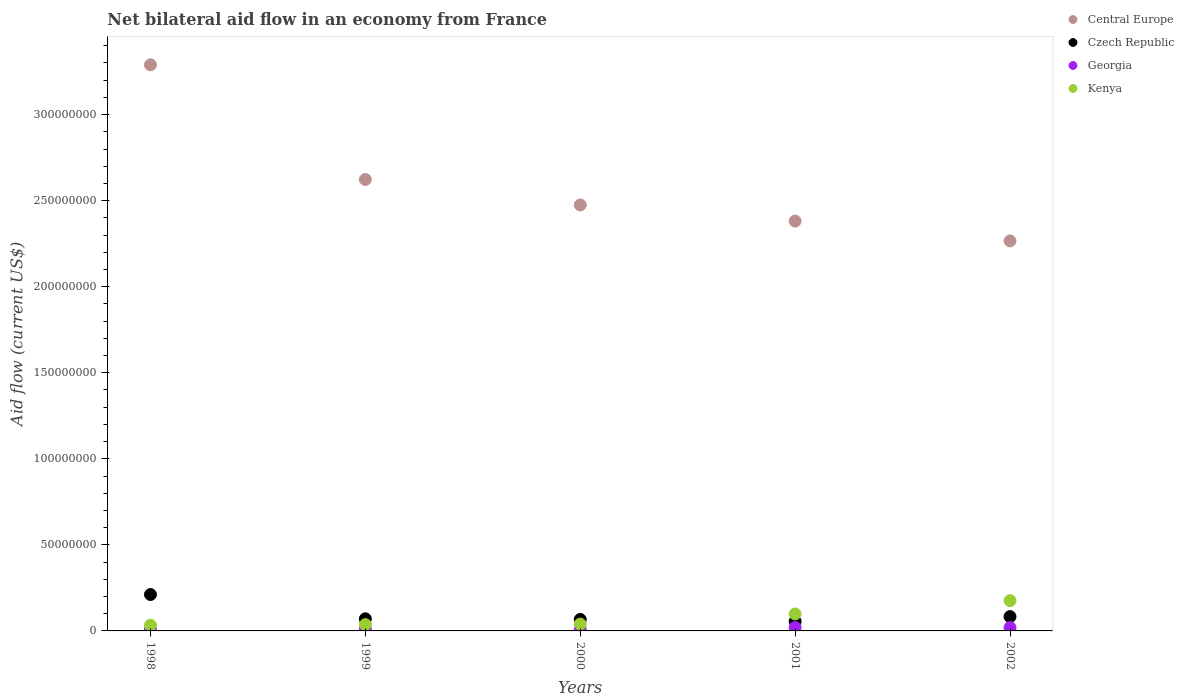How many different coloured dotlines are there?
Give a very brief answer. 4. Is the number of dotlines equal to the number of legend labels?
Your response must be concise. Yes. What is the net bilateral aid flow in Georgia in 2002?
Offer a very short reply. 1.94e+06. Across all years, what is the maximum net bilateral aid flow in Georgia?
Your response must be concise. 1.94e+06. Across all years, what is the minimum net bilateral aid flow in Georgia?
Make the answer very short. 8.10e+05. In which year was the net bilateral aid flow in Czech Republic maximum?
Offer a terse response. 1998. In which year was the net bilateral aid flow in Central Europe minimum?
Provide a succinct answer. 2002. What is the total net bilateral aid flow in Czech Republic in the graph?
Offer a terse response. 4.87e+07. What is the difference between the net bilateral aid flow in Central Europe in 2001 and the net bilateral aid flow in Kenya in 2000?
Your response must be concise. 2.34e+08. What is the average net bilateral aid flow in Georgia per year?
Provide a short and direct response. 1.36e+06. In the year 2000, what is the difference between the net bilateral aid flow in Central Europe and net bilateral aid flow in Georgia?
Provide a succinct answer. 2.47e+08. What is the ratio of the net bilateral aid flow in Central Europe in 1998 to that in 1999?
Your answer should be very brief. 1.25. Is the net bilateral aid flow in Kenya in 1999 less than that in 2002?
Give a very brief answer. Yes. Is the difference between the net bilateral aid flow in Central Europe in 2001 and 2002 greater than the difference between the net bilateral aid flow in Georgia in 2001 and 2002?
Your answer should be compact. Yes. What is the difference between the highest and the lowest net bilateral aid flow in Kenya?
Provide a short and direct response. 1.43e+07. Does the net bilateral aid flow in Kenya monotonically increase over the years?
Your answer should be compact. Yes. Is the net bilateral aid flow in Georgia strictly less than the net bilateral aid flow in Kenya over the years?
Make the answer very short. Yes. How many dotlines are there?
Your response must be concise. 4. Are the values on the major ticks of Y-axis written in scientific E-notation?
Your answer should be compact. No. Does the graph contain any zero values?
Offer a very short reply. No. How are the legend labels stacked?
Provide a succinct answer. Vertical. What is the title of the graph?
Provide a succinct answer. Net bilateral aid flow in an economy from France. What is the label or title of the X-axis?
Offer a very short reply. Years. What is the label or title of the Y-axis?
Provide a succinct answer. Aid flow (current US$). What is the Aid flow (current US$) in Central Europe in 1998?
Ensure brevity in your answer.  3.29e+08. What is the Aid flow (current US$) of Czech Republic in 1998?
Offer a very short reply. 2.12e+07. What is the Aid flow (current US$) of Georgia in 1998?
Your response must be concise. 9.20e+05. What is the Aid flow (current US$) in Kenya in 1998?
Your answer should be compact. 3.33e+06. What is the Aid flow (current US$) of Central Europe in 1999?
Your response must be concise. 2.62e+08. What is the Aid flow (current US$) of Czech Republic in 1999?
Your answer should be compact. 7.03e+06. What is the Aid flow (current US$) in Georgia in 1999?
Give a very brief answer. 1.22e+06. What is the Aid flow (current US$) in Kenya in 1999?
Your answer should be compact. 3.64e+06. What is the Aid flow (current US$) in Central Europe in 2000?
Your response must be concise. 2.48e+08. What is the Aid flow (current US$) in Czech Republic in 2000?
Provide a succinct answer. 6.67e+06. What is the Aid flow (current US$) in Georgia in 2000?
Provide a succinct answer. 8.10e+05. What is the Aid flow (current US$) in Kenya in 2000?
Keep it short and to the point. 3.97e+06. What is the Aid flow (current US$) in Central Europe in 2001?
Your answer should be compact. 2.38e+08. What is the Aid flow (current US$) in Czech Republic in 2001?
Provide a succinct answer. 5.51e+06. What is the Aid flow (current US$) of Georgia in 2001?
Provide a succinct answer. 1.93e+06. What is the Aid flow (current US$) of Kenya in 2001?
Ensure brevity in your answer.  9.86e+06. What is the Aid flow (current US$) in Central Europe in 2002?
Offer a very short reply. 2.27e+08. What is the Aid flow (current US$) of Czech Republic in 2002?
Ensure brevity in your answer.  8.31e+06. What is the Aid flow (current US$) of Georgia in 2002?
Ensure brevity in your answer.  1.94e+06. What is the Aid flow (current US$) of Kenya in 2002?
Keep it short and to the point. 1.76e+07. Across all years, what is the maximum Aid flow (current US$) in Central Europe?
Ensure brevity in your answer.  3.29e+08. Across all years, what is the maximum Aid flow (current US$) of Czech Republic?
Ensure brevity in your answer.  2.12e+07. Across all years, what is the maximum Aid flow (current US$) of Georgia?
Your response must be concise. 1.94e+06. Across all years, what is the maximum Aid flow (current US$) in Kenya?
Give a very brief answer. 1.76e+07. Across all years, what is the minimum Aid flow (current US$) of Central Europe?
Your answer should be very brief. 2.27e+08. Across all years, what is the minimum Aid flow (current US$) in Czech Republic?
Offer a terse response. 5.51e+06. Across all years, what is the minimum Aid flow (current US$) in Georgia?
Provide a short and direct response. 8.10e+05. Across all years, what is the minimum Aid flow (current US$) in Kenya?
Give a very brief answer. 3.33e+06. What is the total Aid flow (current US$) of Central Europe in the graph?
Your answer should be compact. 1.30e+09. What is the total Aid flow (current US$) of Czech Republic in the graph?
Give a very brief answer. 4.87e+07. What is the total Aid flow (current US$) of Georgia in the graph?
Provide a short and direct response. 6.82e+06. What is the total Aid flow (current US$) in Kenya in the graph?
Provide a succinct answer. 3.84e+07. What is the difference between the Aid flow (current US$) in Central Europe in 1998 and that in 1999?
Your answer should be very brief. 6.66e+07. What is the difference between the Aid flow (current US$) of Czech Republic in 1998 and that in 1999?
Provide a short and direct response. 1.41e+07. What is the difference between the Aid flow (current US$) in Georgia in 1998 and that in 1999?
Give a very brief answer. -3.00e+05. What is the difference between the Aid flow (current US$) of Kenya in 1998 and that in 1999?
Keep it short and to the point. -3.10e+05. What is the difference between the Aid flow (current US$) of Central Europe in 1998 and that in 2000?
Offer a very short reply. 8.14e+07. What is the difference between the Aid flow (current US$) in Czech Republic in 1998 and that in 2000?
Provide a short and direct response. 1.45e+07. What is the difference between the Aid flow (current US$) of Georgia in 1998 and that in 2000?
Give a very brief answer. 1.10e+05. What is the difference between the Aid flow (current US$) in Kenya in 1998 and that in 2000?
Ensure brevity in your answer.  -6.40e+05. What is the difference between the Aid flow (current US$) of Central Europe in 1998 and that in 2001?
Make the answer very short. 9.08e+07. What is the difference between the Aid flow (current US$) of Czech Republic in 1998 and that in 2001?
Offer a very short reply. 1.56e+07. What is the difference between the Aid flow (current US$) in Georgia in 1998 and that in 2001?
Offer a very short reply. -1.01e+06. What is the difference between the Aid flow (current US$) of Kenya in 1998 and that in 2001?
Your answer should be very brief. -6.53e+06. What is the difference between the Aid flow (current US$) of Central Europe in 1998 and that in 2002?
Provide a succinct answer. 1.02e+08. What is the difference between the Aid flow (current US$) of Czech Republic in 1998 and that in 2002?
Keep it short and to the point. 1.28e+07. What is the difference between the Aid flow (current US$) in Georgia in 1998 and that in 2002?
Provide a succinct answer. -1.02e+06. What is the difference between the Aid flow (current US$) of Kenya in 1998 and that in 2002?
Offer a terse response. -1.43e+07. What is the difference between the Aid flow (current US$) of Central Europe in 1999 and that in 2000?
Provide a succinct answer. 1.48e+07. What is the difference between the Aid flow (current US$) of Czech Republic in 1999 and that in 2000?
Offer a terse response. 3.60e+05. What is the difference between the Aid flow (current US$) in Kenya in 1999 and that in 2000?
Provide a short and direct response. -3.30e+05. What is the difference between the Aid flow (current US$) of Central Europe in 1999 and that in 2001?
Provide a succinct answer. 2.42e+07. What is the difference between the Aid flow (current US$) in Czech Republic in 1999 and that in 2001?
Offer a terse response. 1.52e+06. What is the difference between the Aid flow (current US$) in Georgia in 1999 and that in 2001?
Your answer should be compact. -7.10e+05. What is the difference between the Aid flow (current US$) in Kenya in 1999 and that in 2001?
Your answer should be compact. -6.22e+06. What is the difference between the Aid flow (current US$) in Central Europe in 1999 and that in 2002?
Make the answer very short. 3.57e+07. What is the difference between the Aid flow (current US$) in Czech Republic in 1999 and that in 2002?
Your answer should be compact. -1.28e+06. What is the difference between the Aid flow (current US$) of Georgia in 1999 and that in 2002?
Keep it short and to the point. -7.20e+05. What is the difference between the Aid flow (current US$) of Kenya in 1999 and that in 2002?
Your response must be concise. -1.40e+07. What is the difference between the Aid flow (current US$) of Central Europe in 2000 and that in 2001?
Provide a short and direct response. 9.37e+06. What is the difference between the Aid flow (current US$) in Czech Republic in 2000 and that in 2001?
Provide a short and direct response. 1.16e+06. What is the difference between the Aid flow (current US$) of Georgia in 2000 and that in 2001?
Provide a short and direct response. -1.12e+06. What is the difference between the Aid flow (current US$) in Kenya in 2000 and that in 2001?
Offer a terse response. -5.89e+06. What is the difference between the Aid flow (current US$) of Central Europe in 2000 and that in 2002?
Make the answer very short. 2.09e+07. What is the difference between the Aid flow (current US$) of Czech Republic in 2000 and that in 2002?
Offer a very short reply. -1.64e+06. What is the difference between the Aid flow (current US$) in Georgia in 2000 and that in 2002?
Make the answer very short. -1.13e+06. What is the difference between the Aid flow (current US$) in Kenya in 2000 and that in 2002?
Offer a very short reply. -1.36e+07. What is the difference between the Aid flow (current US$) in Central Europe in 2001 and that in 2002?
Make the answer very short. 1.15e+07. What is the difference between the Aid flow (current US$) in Czech Republic in 2001 and that in 2002?
Your response must be concise. -2.80e+06. What is the difference between the Aid flow (current US$) of Georgia in 2001 and that in 2002?
Give a very brief answer. -10000. What is the difference between the Aid flow (current US$) of Kenya in 2001 and that in 2002?
Offer a very short reply. -7.74e+06. What is the difference between the Aid flow (current US$) of Central Europe in 1998 and the Aid flow (current US$) of Czech Republic in 1999?
Provide a short and direct response. 3.22e+08. What is the difference between the Aid flow (current US$) of Central Europe in 1998 and the Aid flow (current US$) of Georgia in 1999?
Your answer should be compact. 3.28e+08. What is the difference between the Aid flow (current US$) in Central Europe in 1998 and the Aid flow (current US$) in Kenya in 1999?
Offer a terse response. 3.25e+08. What is the difference between the Aid flow (current US$) of Czech Republic in 1998 and the Aid flow (current US$) of Georgia in 1999?
Provide a short and direct response. 1.99e+07. What is the difference between the Aid flow (current US$) in Czech Republic in 1998 and the Aid flow (current US$) in Kenya in 1999?
Your answer should be compact. 1.75e+07. What is the difference between the Aid flow (current US$) in Georgia in 1998 and the Aid flow (current US$) in Kenya in 1999?
Provide a succinct answer. -2.72e+06. What is the difference between the Aid flow (current US$) of Central Europe in 1998 and the Aid flow (current US$) of Czech Republic in 2000?
Your response must be concise. 3.22e+08. What is the difference between the Aid flow (current US$) in Central Europe in 1998 and the Aid flow (current US$) in Georgia in 2000?
Ensure brevity in your answer.  3.28e+08. What is the difference between the Aid flow (current US$) of Central Europe in 1998 and the Aid flow (current US$) of Kenya in 2000?
Ensure brevity in your answer.  3.25e+08. What is the difference between the Aid flow (current US$) in Czech Republic in 1998 and the Aid flow (current US$) in Georgia in 2000?
Your answer should be very brief. 2.03e+07. What is the difference between the Aid flow (current US$) in Czech Republic in 1998 and the Aid flow (current US$) in Kenya in 2000?
Give a very brief answer. 1.72e+07. What is the difference between the Aid flow (current US$) of Georgia in 1998 and the Aid flow (current US$) of Kenya in 2000?
Provide a succinct answer. -3.05e+06. What is the difference between the Aid flow (current US$) of Central Europe in 1998 and the Aid flow (current US$) of Czech Republic in 2001?
Your answer should be compact. 3.23e+08. What is the difference between the Aid flow (current US$) of Central Europe in 1998 and the Aid flow (current US$) of Georgia in 2001?
Your answer should be compact. 3.27e+08. What is the difference between the Aid flow (current US$) in Central Europe in 1998 and the Aid flow (current US$) in Kenya in 2001?
Ensure brevity in your answer.  3.19e+08. What is the difference between the Aid flow (current US$) in Czech Republic in 1998 and the Aid flow (current US$) in Georgia in 2001?
Provide a short and direct response. 1.92e+07. What is the difference between the Aid flow (current US$) in Czech Republic in 1998 and the Aid flow (current US$) in Kenya in 2001?
Ensure brevity in your answer.  1.13e+07. What is the difference between the Aid flow (current US$) in Georgia in 1998 and the Aid flow (current US$) in Kenya in 2001?
Make the answer very short. -8.94e+06. What is the difference between the Aid flow (current US$) in Central Europe in 1998 and the Aid flow (current US$) in Czech Republic in 2002?
Give a very brief answer. 3.21e+08. What is the difference between the Aid flow (current US$) of Central Europe in 1998 and the Aid flow (current US$) of Georgia in 2002?
Give a very brief answer. 3.27e+08. What is the difference between the Aid flow (current US$) in Central Europe in 1998 and the Aid flow (current US$) in Kenya in 2002?
Your response must be concise. 3.11e+08. What is the difference between the Aid flow (current US$) in Czech Republic in 1998 and the Aid flow (current US$) in Georgia in 2002?
Offer a terse response. 1.92e+07. What is the difference between the Aid flow (current US$) in Czech Republic in 1998 and the Aid flow (current US$) in Kenya in 2002?
Your answer should be very brief. 3.55e+06. What is the difference between the Aid flow (current US$) of Georgia in 1998 and the Aid flow (current US$) of Kenya in 2002?
Provide a short and direct response. -1.67e+07. What is the difference between the Aid flow (current US$) in Central Europe in 1999 and the Aid flow (current US$) in Czech Republic in 2000?
Keep it short and to the point. 2.56e+08. What is the difference between the Aid flow (current US$) of Central Europe in 1999 and the Aid flow (current US$) of Georgia in 2000?
Offer a terse response. 2.61e+08. What is the difference between the Aid flow (current US$) of Central Europe in 1999 and the Aid flow (current US$) of Kenya in 2000?
Make the answer very short. 2.58e+08. What is the difference between the Aid flow (current US$) in Czech Republic in 1999 and the Aid flow (current US$) in Georgia in 2000?
Offer a very short reply. 6.22e+06. What is the difference between the Aid flow (current US$) in Czech Republic in 1999 and the Aid flow (current US$) in Kenya in 2000?
Offer a terse response. 3.06e+06. What is the difference between the Aid flow (current US$) of Georgia in 1999 and the Aid flow (current US$) of Kenya in 2000?
Your answer should be very brief. -2.75e+06. What is the difference between the Aid flow (current US$) of Central Europe in 1999 and the Aid flow (current US$) of Czech Republic in 2001?
Keep it short and to the point. 2.57e+08. What is the difference between the Aid flow (current US$) of Central Europe in 1999 and the Aid flow (current US$) of Georgia in 2001?
Ensure brevity in your answer.  2.60e+08. What is the difference between the Aid flow (current US$) of Central Europe in 1999 and the Aid flow (current US$) of Kenya in 2001?
Your answer should be compact. 2.52e+08. What is the difference between the Aid flow (current US$) of Czech Republic in 1999 and the Aid flow (current US$) of Georgia in 2001?
Ensure brevity in your answer.  5.10e+06. What is the difference between the Aid flow (current US$) in Czech Republic in 1999 and the Aid flow (current US$) in Kenya in 2001?
Your response must be concise. -2.83e+06. What is the difference between the Aid flow (current US$) of Georgia in 1999 and the Aid flow (current US$) of Kenya in 2001?
Give a very brief answer. -8.64e+06. What is the difference between the Aid flow (current US$) in Central Europe in 1999 and the Aid flow (current US$) in Czech Republic in 2002?
Your answer should be very brief. 2.54e+08. What is the difference between the Aid flow (current US$) in Central Europe in 1999 and the Aid flow (current US$) in Georgia in 2002?
Give a very brief answer. 2.60e+08. What is the difference between the Aid flow (current US$) of Central Europe in 1999 and the Aid flow (current US$) of Kenya in 2002?
Keep it short and to the point. 2.45e+08. What is the difference between the Aid flow (current US$) in Czech Republic in 1999 and the Aid flow (current US$) in Georgia in 2002?
Your answer should be very brief. 5.09e+06. What is the difference between the Aid flow (current US$) in Czech Republic in 1999 and the Aid flow (current US$) in Kenya in 2002?
Ensure brevity in your answer.  -1.06e+07. What is the difference between the Aid flow (current US$) of Georgia in 1999 and the Aid flow (current US$) of Kenya in 2002?
Your answer should be compact. -1.64e+07. What is the difference between the Aid flow (current US$) in Central Europe in 2000 and the Aid flow (current US$) in Czech Republic in 2001?
Your response must be concise. 2.42e+08. What is the difference between the Aid flow (current US$) in Central Europe in 2000 and the Aid flow (current US$) in Georgia in 2001?
Offer a terse response. 2.46e+08. What is the difference between the Aid flow (current US$) of Central Europe in 2000 and the Aid flow (current US$) of Kenya in 2001?
Make the answer very short. 2.38e+08. What is the difference between the Aid flow (current US$) in Czech Republic in 2000 and the Aid flow (current US$) in Georgia in 2001?
Your response must be concise. 4.74e+06. What is the difference between the Aid flow (current US$) in Czech Republic in 2000 and the Aid flow (current US$) in Kenya in 2001?
Your response must be concise. -3.19e+06. What is the difference between the Aid flow (current US$) in Georgia in 2000 and the Aid flow (current US$) in Kenya in 2001?
Your answer should be compact. -9.05e+06. What is the difference between the Aid flow (current US$) in Central Europe in 2000 and the Aid flow (current US$) in Czech Republic in 2002?
Make the answer very short. 2.39e+08. What is the difference between the Aid flow (current US$) of Central Europe in 2000 and the Aid flow (current US$) of Georgia in 2002?
Ensure brevity in your answer.  2.46e+08. What is the difference between the Aid flow (current US$) in Central Europe in 2000 and the Aid flow (current US$) in Kenya in 2002?
Your response must be concise. 2.30e+08. What is the difference between the Aid flow (current US$) of Czech Republic in 2000 and the Aid flow (current US$) of Georgia in 2002?
Offer a very short reply. 4.73e+06. What is the difference between the Aid flow (current US$) of Czech Republic in 2000 and the Aid flow (current US$) of Kenya in 2002?
Offer a terse response. -1.09e+07. What is the difference between the Aid flow (current US$) of Georgia in 2000 and the Aid flow (current US$) of Kenya in 2002?
Ensure brevity in your answer.  -1.68e+07. What is the difference between the Aid flow (current US$) of Central Europe in 2001 and the Aid flow (current US$) of Czech Republic in 2002?
Your answer should be very brief. 2.30e+08. What is the difference between the Aid flow (current US$) in Central Europe in 2001 and the Aid flow (current US$) in Georgia in 2002?
Provide a short and direct response. 2.36e+08. What is the difference between the Aid flow (current US$) of Central Europe in 2001 and the Aid flow (current US$) of Kenya in 2002?
Your answer should be very brief. 2.21e+08. What is the difference between the Aid flow (current US$) of Czech Republic in 2001 and the Aid flow (current US$) of Georgia in 2002?
Make the answer very short. 3.57e+06. What is the difference between the Aid flow (current US$) in Czech Republic in 2001 and the Aid flow (current US$) in Kenya in 2002?
Provide a short and direct response. -1.21e+07. What is the difference between the Aid flow (current US$) of Georgia in 2001 and the Aid flow (current US$) of Kenya in 2002?
Provide a short and direct response. -1.57e+07. What is the average Aid flow (current US$) in Central Europe per year?
Give a very brief answer. 2.61e+08. What is the average Aid flow (current US$) of Czech Republic per year?
Ensure brevity in your answer.  9.73e+06. What is the average Aid flow (current US$) of Georgia per year?
Give a very brief answer. 1.36e+06. What is the average Aid flow (current US$) of Kenya per year?
Offer a very short reply. 7.68e+06. In the year 1998, what is the difference between the Aid flow (current US$) of Central Europe and Aid flow (current US$) of Czech Republic?
Your response must be concise. 3.08e+08. In the year 1998, what is the difference between the Aid flow (current US$) of Central Europe and Aid flow (current US$) of Georgia?
Your answer should be very brief. 3.28e+08. In the year 1998, what is the difference between the Aid flow (current US$) in Central Europe and Aid flow (current US$) in Kenya?
Your response must be concise. 3.26e+08. In the year 1998, what is the difference between the Aid flow (current US$) in Czech Republic and Aid flow (current US$) in Georgia?
Your response must be concise. 2.02e+07. In the year 1998, what is the difference between the Aid flow (current US$) in Czech Republic and Aid flow (current US$) in Kenya?
Your response must be concise. 1.78e+07. In the year 1998, what is the difference between the Aid flow (current US$) in Georgia and Aid flow (current US$) in Kenya?
Keep it short and to the point. -2.41e+06. In the year 1999, what is the difference between the Aid flow (current US$) of Central Europe and Aid flow (current US$) of Czech Republic?
Offer a very short reply. 2.55e+08. In the year 1999, what is the difference between the Aid flow (current US$) of Central Europe and Aid flow (current US$) of Georgia?
Your response must be concise. 2.61e+08. In the year 1999, what is the difference between the Aid flow (current US$) in Central Europe and Aid flow (current US$) in Kenya?
Make the answer very short. 2.59e+08. In the year 1999, what is the difference between the Aid flow (current US$) of Czech Republic and Aid flow (current US$) of Georgia?
Keep it short and to the point. 5.81e+06. In the year 1999, what is the difference between the Aid flow (current US$) in Czech Republic and Aid flow (current US$) in Kenya?
Your response must be concise. 3.39e+06. In the year 1999, what is the difference between the Aid flow (current US$) in Georgia and Aid flow (current US$) in Kenya?
Offer a terse response. -2.42e+06. In the year 2000, what is the difference between the Aid flow (current US$) of Central Europe and Aid flow (current US$) of Czech Republic?
Offer a terse response. 2.41e+08. In the year 2000, what is the difference between the Aid flow (current US$) in Central Europe and Aid flow (current US$) in Georgia?
Offer a very short reply. 2.47e+08. In the year 2000, what is the difference between the Aid flow (current US$) in Central Europe and Aid flow (current US$) in Kenya?
Keep it short and to the point. 2.44e+08. In the year 2000, what is the difference between the Aid flow (current US$) in Czech Republic and Aid flow (current US$) in Georgia?
Provide a succinct answer. 5.86e+06. In the year 2000, what is the difference between the Aid flow (current US$) in Czech Republic and Aid flow (current US$) in Kenya?
Keep it short and to the point. 2.70e+06. In the year 2000, what is the difference between the Aid flow (current US$) in Georgia and Aid flow (current US$) in Kenya?
Provide a short and direct response. -3.16e+06. In the year 2001, what is the difference between the Aid flow (current US$) in Central Europe and Aid flow (current US$) in Czech Republic?
Your response must be concise. 2.33e+08. In the year 2001, what is the difference between the Aid flow (current US$) of Central Europe and Aid flow (current US$) of Georgia?
Your answer should be compact. 2.36e+08. In the year 2001, what is the difference between the Aid flow (current US$) in Central Europe and Aid flow (current US$) in Kenya?
Offer a terse response. 2.28e+08. In the year 2001, what is the difference between the Aid flow (current US$) in Czech Republic and Aid flow (current US$) in Georgia?
Offer a very short reply. 3.58e+06. In the year 2001, what is the difference between the Aid flow (current US$) of Czech Republic and Aid flow (current US$) of Kenya?
Your answer should be very brief. -4.35e+06. In the year 2001, what is the difference between the Aid flow (current US$) in Georgia and Aid flow (current US$) in Kenya?
Make the answer very short. -7.93e+06. In the year 2002, what is the difference between the Aid flow (current US$) of Central Europe and Aid flow (current US$) of Czech Republic?
Your response must be concise. 2.18e+08. In the year 2002, what is the difference between the Aid flow (current US$) of Central Europe and Aid flow (current US$) of Georgia?
Your answer should be very brief. 2.25e+08. In the year 2002, what is the difference between the Aid flow (current US$) in Central Europe and Aid flow (current US$) in Kenya?
Make the answer very short. 2.09e+08. In the year 2002, what is the difference between the Aid flow (current US$) in Czech Republic and Aid flow (current US$) in Georgia?
Ensure brevity in your answer.  6.37e+06. In the year 2002, what is the difference between the Aid flow (current US$) of Czech Republic and Aid flow (current US$) of Kenya?
Ensure brevity in your answer.  -9.29e+06. In the year 2002, what is the difference between the Aid flow (current US$) in Georgia and Aid flow (current US$) in Kenya?
Keep it short and to the point. -1.57e+07. What is the ratio of the Aid flow (current US$) in Central Europe in 1998 to that in 1999?
Keep it short and to the point. 1.25. What is the ratio of the Aid flow (current US$) in Czech Republic in 1998 to that in 1999?
Provide a succinct answer. 3.01. What is the ratio of the Aid flow (current US$) in Georgia in 1998 to that in 1999?
Your response must be concise. 0.75. What is the ratio of the Aid flow (current US$) of Kenya in 1998 to that in 1999?
Your answer should be compact. 0.91. What is the ratio of the Aid flow (current US$) of Central Europe in 1998 to that in 2000?
Your answer should be very brief. 1.33. What is the ratio of the Aid flow (current US$) in Czech Republic in 1998 to that in 2000?
Give a very brief answer. 3.17. What is the ratio of the Aid flow (current US$) of Georgia in 1998 to that in 2000?
Keep it short and to the point. 1.14. What is the ratio of the Aid flow (current US$) of Kenya in 1998 to that in 2000?
Your response must be concise. 0.84. What is the ratio of the Aid flow (current US$) in Central Europe in 1998 to that in 2001?
Give a very brief answer. 1.38. What is the ratio of the Aid flow (current US$) of Czech Republic in 1998 to that in 2001?
Your answer should be compact. 3.84. What is the ratio of the Aid flow (current US$) in Georgia in 1998 to that in 2001?
Ensure brevity in your answer.  0.48. What is the ratio of the Aid flow (current US$) in Kenya in 1998 to that in 2001?
Make the answer very short. 0.34. What is the ratio of the Aid flow (current US$) in Central Europe in 1998 to that in 2002?
Make the answer very short. 1.45. What is the ratio of the Aid flow (current US$) in Czech Republic in 1998 to that in 2002?
Provide a succinct answer. 2.55. What is the ratio of the Aid flow (current US$) of Georgia in 1998 to that in 2002?
Give a very brief answer. 0.47. What is the ratio of the Aid flow (current US$) in Kenya in 1998 to that in 2002?
Provide a short and direct response. 0.19. What is the ratio of the Aid flow (current US$) of Central Europe in 1999 to that in 2000?
Your answer should be compact. 1.06. What is the ratio of the Aid flow (current US$) in Czech Republic in 1999 to that in 2000?
Provide a short and direct response. 1.05. What is the ratio of the Aid flow (current US$) in Georgia in 1999 to that in 2000?
Your answer should be very brief. 1.51. What is the ratio of the Aid flow (current US$) of Kenya in 1999 to that in 2000?
Your answer should be very brief. 0.92. What is the ratio of the Aid flow (current US$) of Central Europe in 1999 to that in 2001?
Keep it short and to the point. 1.1. What is the ratio of the Aid flow (current US$) of Czech Republic in 1999 to that in 2001?
Provide a succinct answer. 1.28. What is the ratio of the Aid flow (current US$) of Georgia in 1999 to that in 2001?
Your answer should be compact. 0.63. What is the ratio of the Aid flow (current US$) in Kenya in 1999 to that in 2001?
Give a very brief answer. 0.37. What is the ratio of the Aid flow (current US$) of Central Europe in 1999 to that in 2002?
Your answer should be very brief. 1.16. What is the ratio of the Aid flow (current US$) in Czech Republic in 1999 to that in 2002?
Provide a short and direct response. 0.85. What is the ratio of the Aid flow (current US$) in Georgia in 1999 to that in 2002?
Offer a very short reply. 0.63. What is the ratio of the Aid flow (current US$) of Kenya in 1999 to that in 2002?
Ensure brevity in your answer.  0.21. What is the ratio of the Aid flow (current US$) in Central Europe in 2000 to that in 2001?
Provide a succinct answer. 1.04. What is the ratio of the Aid flow (current US$) in Czech Republic in 2000 to that in 2001?
Offer a very short reply. 1.21. What is the ratio of the Aid flow (current US$) of Georgia in 2000 to that in 2001?
Offer a terse response. 0.42. What is the ratio of the Aid flow (current US$) of Kenya in 2000 to that in 2001?
Your answer should be compact. 0.4. What is the ratio of the Aid flow (current US$) in Central Europe in 2000 to that in 2002?
Ensure brevity in your answer.  1.09. What is the ratio of the Aid flow (current US$) in Czech Republic in 2000 to that in 2002?
Ensure brevity in your answer.  0.8. What is the ratio of the Aid flow (current US$) in Georgia in 2000 to that in 2002?
Offer a very short reply. 0.42. What is the ratio of the Aid flow (current US$) of Kenya in 2000 to that in 2002?
Your response must be concise. 0.23. What is the ratio of the Aid flow (current US$) in Central Europe in 2001 to that in 2002?
Ensure brevity in your answer.  1.05. What is the ratio of the Aid flow (current US$) in Czech Republic in 2001 to that in 2002?
Offer a terse response. 0.66. What is the ratio of the Aid flow (current US$) in Kenya in 2001 to that in 2002?
Make the answer very short. 0.56. What is the difference between the highest and the second highest Aid flow (current US$) in Central Europe?
Your response must be concise. 6.66e+07. What is the difference between the highest and the second highest Aid flow (current US$) in Czech Republic?
Ensure brevity in your answer.  1.28e+07. What is the difference between the highest and the second highest Aid flow (current US$) of Kenya?
Keep it short and to the point. 7.74e+06. What is the difference between the highest and the lowest Aid flow (current US$) of Central Europe?
Offer a terse response. 1.02e+08. What is the difference between the highest and the lowest Aid flow (current US$) in Czech Republic?
Offer a terse response. 1.56e+07. What is the difference between the highest and the lowest Aid flow (current US$) in Georgia?
Offer a very short reply. 1.13e+06. What is the difference between the highest and the lowest Aid flow (current US$) of Kenya?
Ensure brevity in your answer.  1.43e+07. 